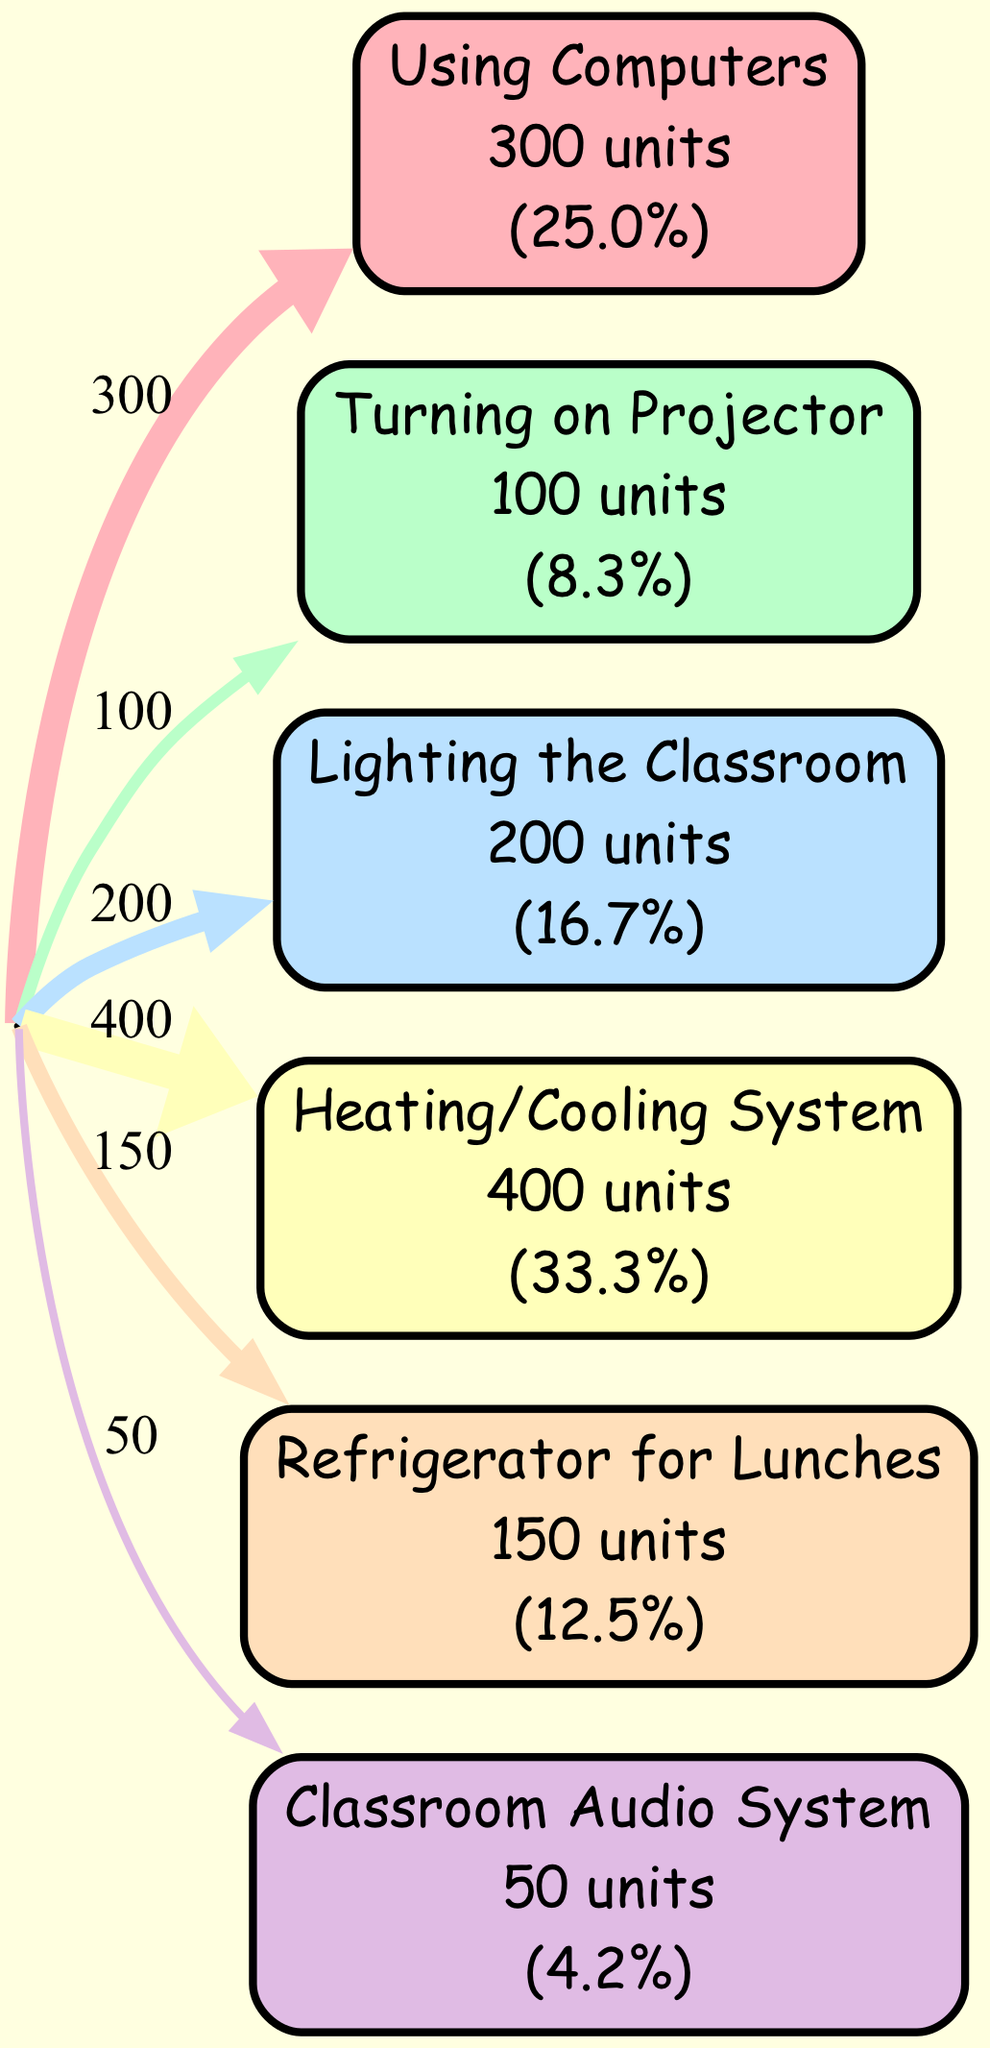What is the energy consumption of using computers? The diagram presents the energy consumption of various classroom activities. To find the energy consumption for using computers, we can locate the corresponding node and read the value. In this case, "Using Computers" has an energy consumption of 300 units.
Answer: 300 Which activity uses more energy, lighting the classroom or the heating/cooling system? We compare the energy consumption values displayed for both "Lighting the Classroom" (200 units) and "Heating/Cooling System" (400 units). Since 400 is greater than 200, the heating/cooling system uses more energy.
Answer: Heating/Cooling System How many activities have energy consumption greater than zero? The diagram lists several activities, and we need to count how many of these have energy consumption values greater than zero. A quick count reveals six activities with non-zero consumption, as "Using Whiteboard Markers (manual activity)" has zero consumption.
Answer: 6 What percentage of the total energy consumption is used for the refrigerator for lunches? To determine this percentage, we first calculate the total energy consumption, which is 300 + 100 + 200 + 400 + 150 + 50 + 0 = 1300 units. Next, we find the energy for the refrigerator (150 units) and calculate the percentage: (150 / 1300) * 100 = 11.5%.
Answer: 11.5% Which activity has the lowest energy consumption? The diagram shows that "Classroom Audio System" has the lowest energy consumption at 50 units. By checking the energy values, we can confirm that this is the lowest among all other activities listed.
Answer: Classroom Audio System How much energy is consumed in total by using the lighting and the projector together? To find the total energy for lighting and the projector, we take the consumption of each: Lighting the Classroom (200 units) + Turning on Projector (100 units) = 300 units. Therefore, their combined energy consumption is 300 units.
Answer: 300 What is the ratio of energy consumed by using computers to that of the refrigerator for lunches? We take the energy values for both activities: Using Computers (300 units) and Refrigerator for Lunches (150 units). The ratio is calculated as 300 / 150 = 2, indicating that using computers consumes twice the energy compared to the refrigerator.
Answer: 2 Which activity uses less than 100 units of energy? We can check the energy values of each activity, and it's clear that "Classroom Audio System", which uses 50 units, is the only one that falls under the threshold of 100 units.
Answer: Classroom Audio System 